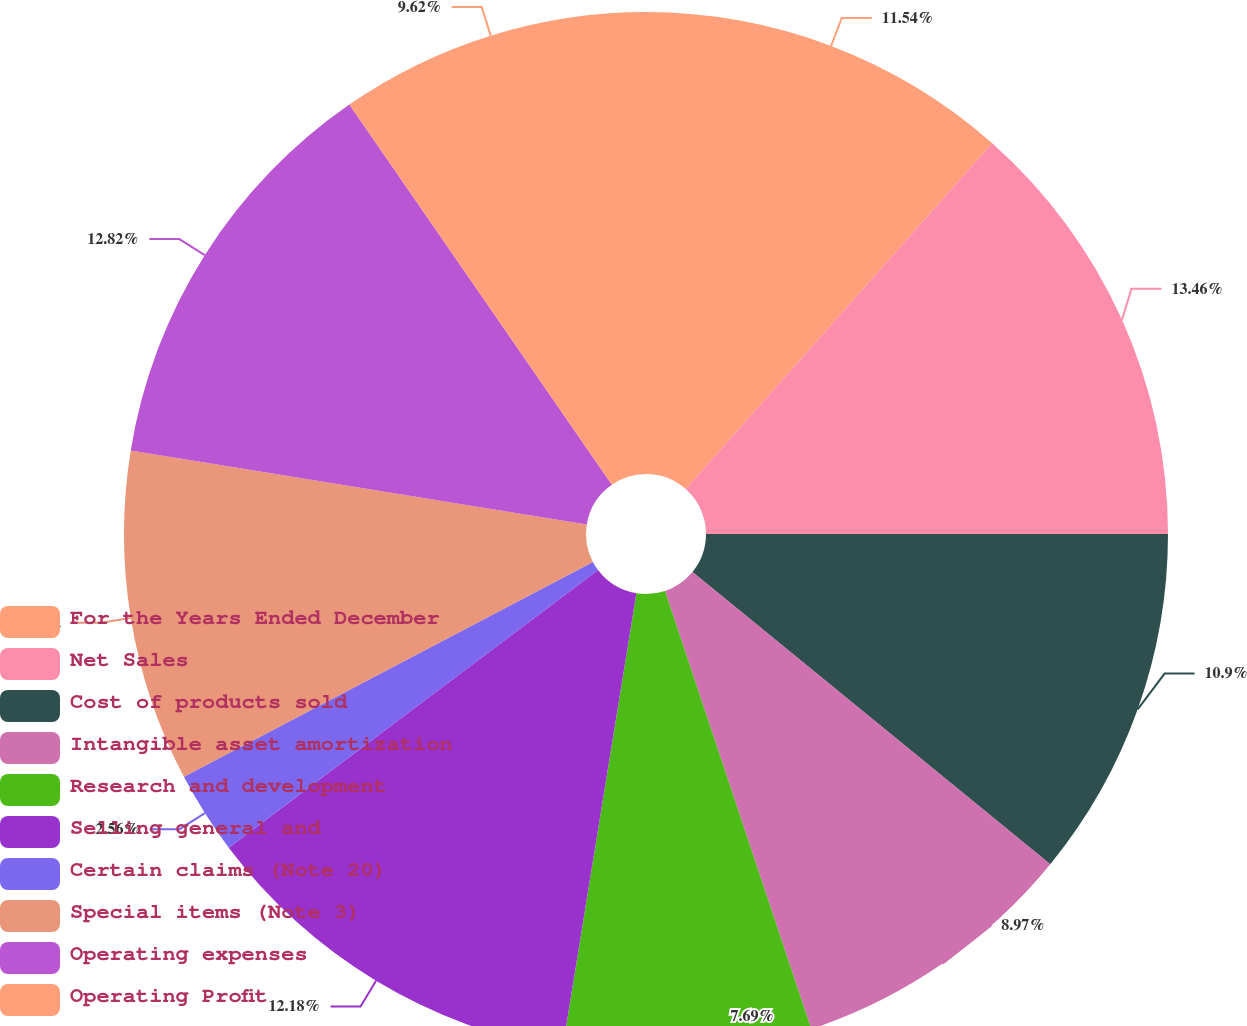Convert chart to OTSL. <chart><loc_0><loc_0><loc_500><loc_500><pie_chart><fcel>For the Years Ended December<fcel>Net Sales<fcel>Cost of products sold<fcel>Intangible asset amortization<fcel>Research and development<fcel>Selling general and<fcel>Certain claims (Note 20)<fcel>Special items (Note 3)<fcel>Operating expenses<fcel>Operating Profit<nl><fcel>11.54%<fcel>13.46%<fcel>10.9%<fcel>8.97%<fcel>7.69%<fcel>12.18%<fcel>2.56%<fcel>10.26%<fcel>12.82%<fcel>9.62%<nl></chart> 